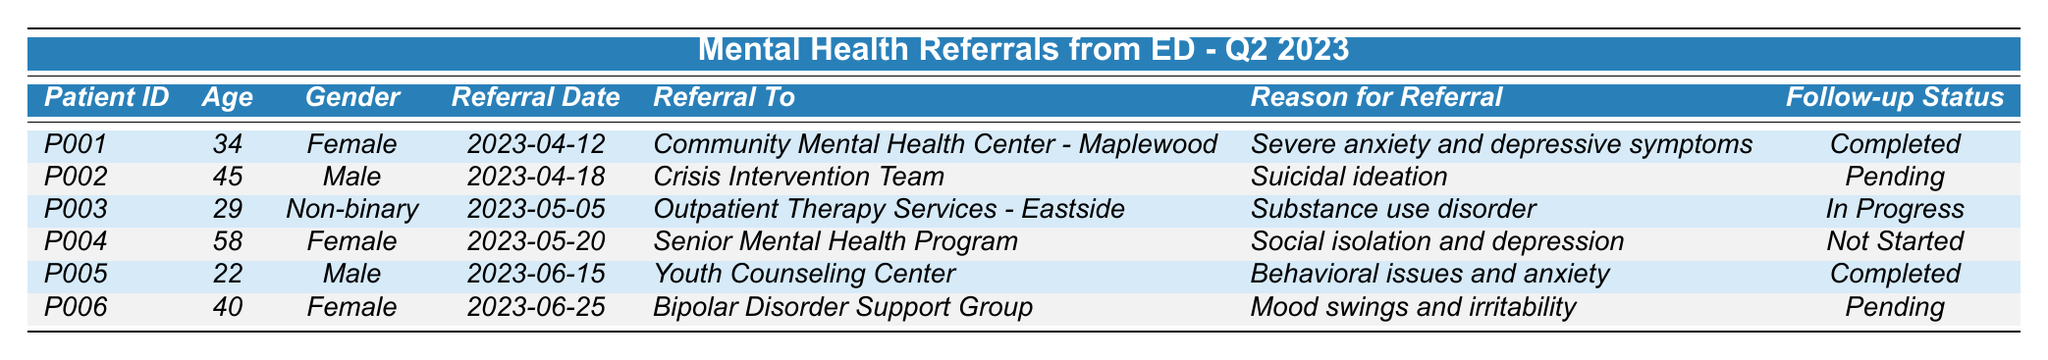What is the referral date for patient P003? The referral date for patient P003 can be found directly in the table under the "Referral Date" column. It shows "2023-05-05".
Answer: 2023-05-05 How many patients have a follow-up status of "Completed"? There are two patients listed with a follow-up status of "Completed": P001 and P005. We can count them directly from the "Follow-up Status" column.
Answer: 2 Who was referred to the "Crisis Intervention Team"? Patient P002 is the one referred to the "Crisis Intervention Team", as noted in the "Referral To" column for that patient.
Answer: P002 Is there any patient referred for "Suicidal ideation"? Yes, patient P002 was referred for "Suicidal ideation" as described in the "Reason for Referral" column.
Answer: Yes What is the average age of the patients who were referred? To find the average age, we can sum the ages (34 + 45 + 29 + 58 + 22 + 40 = 228) and divide by the number of patients (6). The average is 228 / 6 = 38.
Answer: 38 How many patients are still in progress or pending for their follow-ups? The follow-up statuses include "In Progress" for P003 and "Pending" for P002 and P006. Counting these, there are three patients still in progress or pending.
Answer: 3 What is the most common reason for referral among the patients? We can analyze the reasons listed: "Severe anxiety and depressive symptoms", "Suicidal ideation", "Substance use disorder", "Social isolation and depression", "Behavioral issues and anxiety", and "Mood swings and irritability". Each reason is unique with no repetition. Thus, there is no common reason among the patients.
Answer: No common reason What are the genders of the patients who were referred to the "Youth Counseling Center"? Patient P005 is referred to the "Youth Counseling Center", and their gender is Male, as indicated in the "Gender" column.
Answer: Male Based on the table, which patient referred to a program related to older adults and what was their follow-up status? Patient P004 was referred to the "Senior Mental Health Program", which relates to older adults. Their follow-up status is "Not Started".
Answer: P004, Not Started What is the age of the only non-binary patient in the referrals? The only non-binary patient listed is P003, and their age is 29, which can be retrieved directly from the table.
Answer: 29 